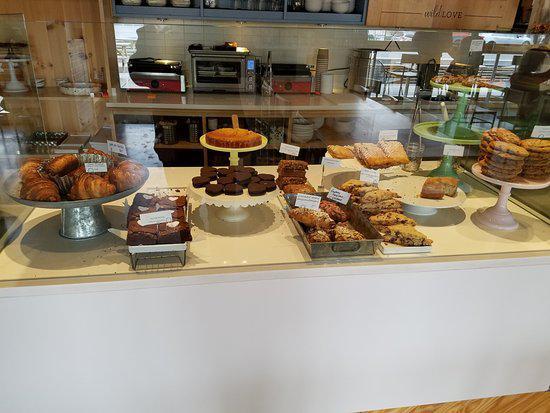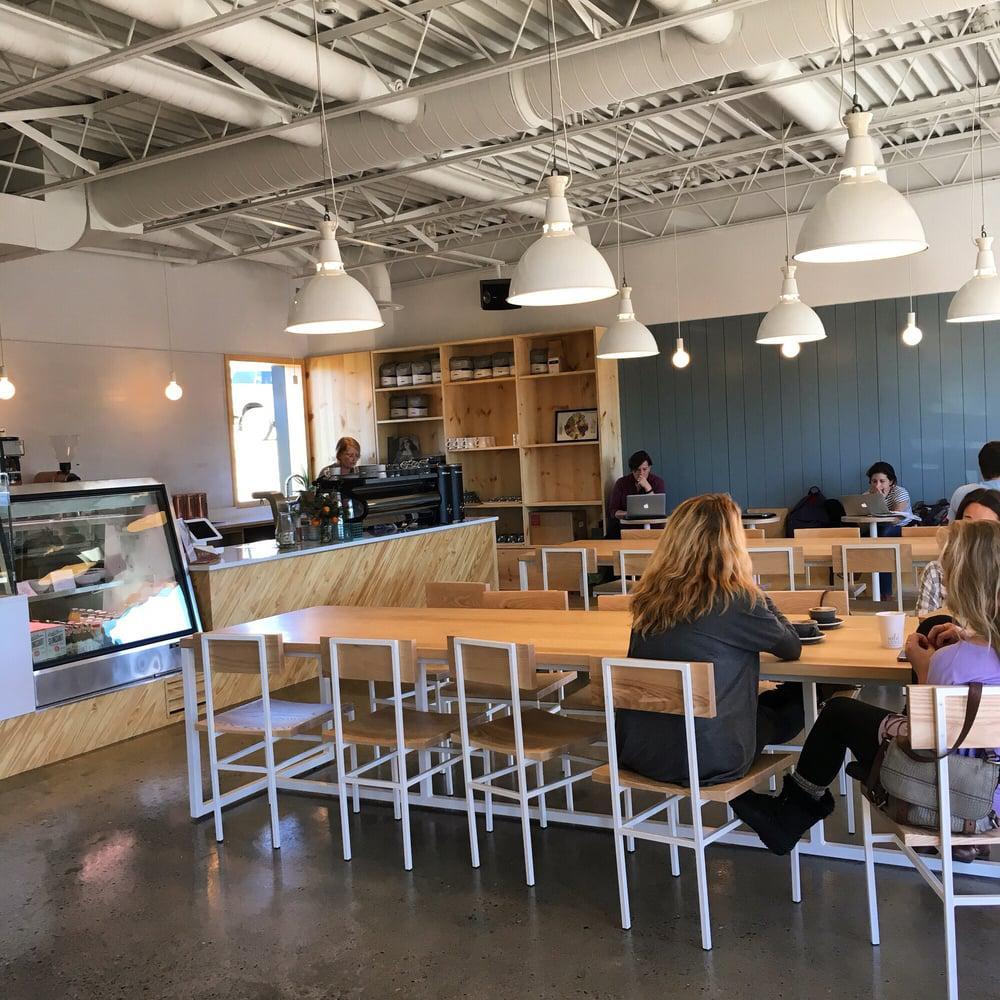The first image is the image on the left, the second image is the image on the right. Assess this claim about the two images: "In at least one image you can see at least 5 adults sitting in  white and light brown chair with at least 5 visible  dropped white lights.". Correct or not? Answer yes or no. Yes. The first image is the image on the left, the second image is the image on the right. Given the left and right images, does the statement "White lamps hang down over tables in a bakery in one of the images." hold true? Answer yes or no. Yes. 